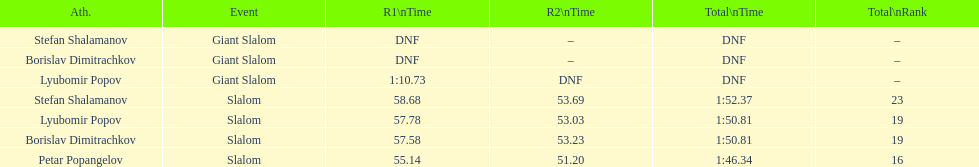What is the difference in time for petar popangelov in race 1and 2 3.94. 